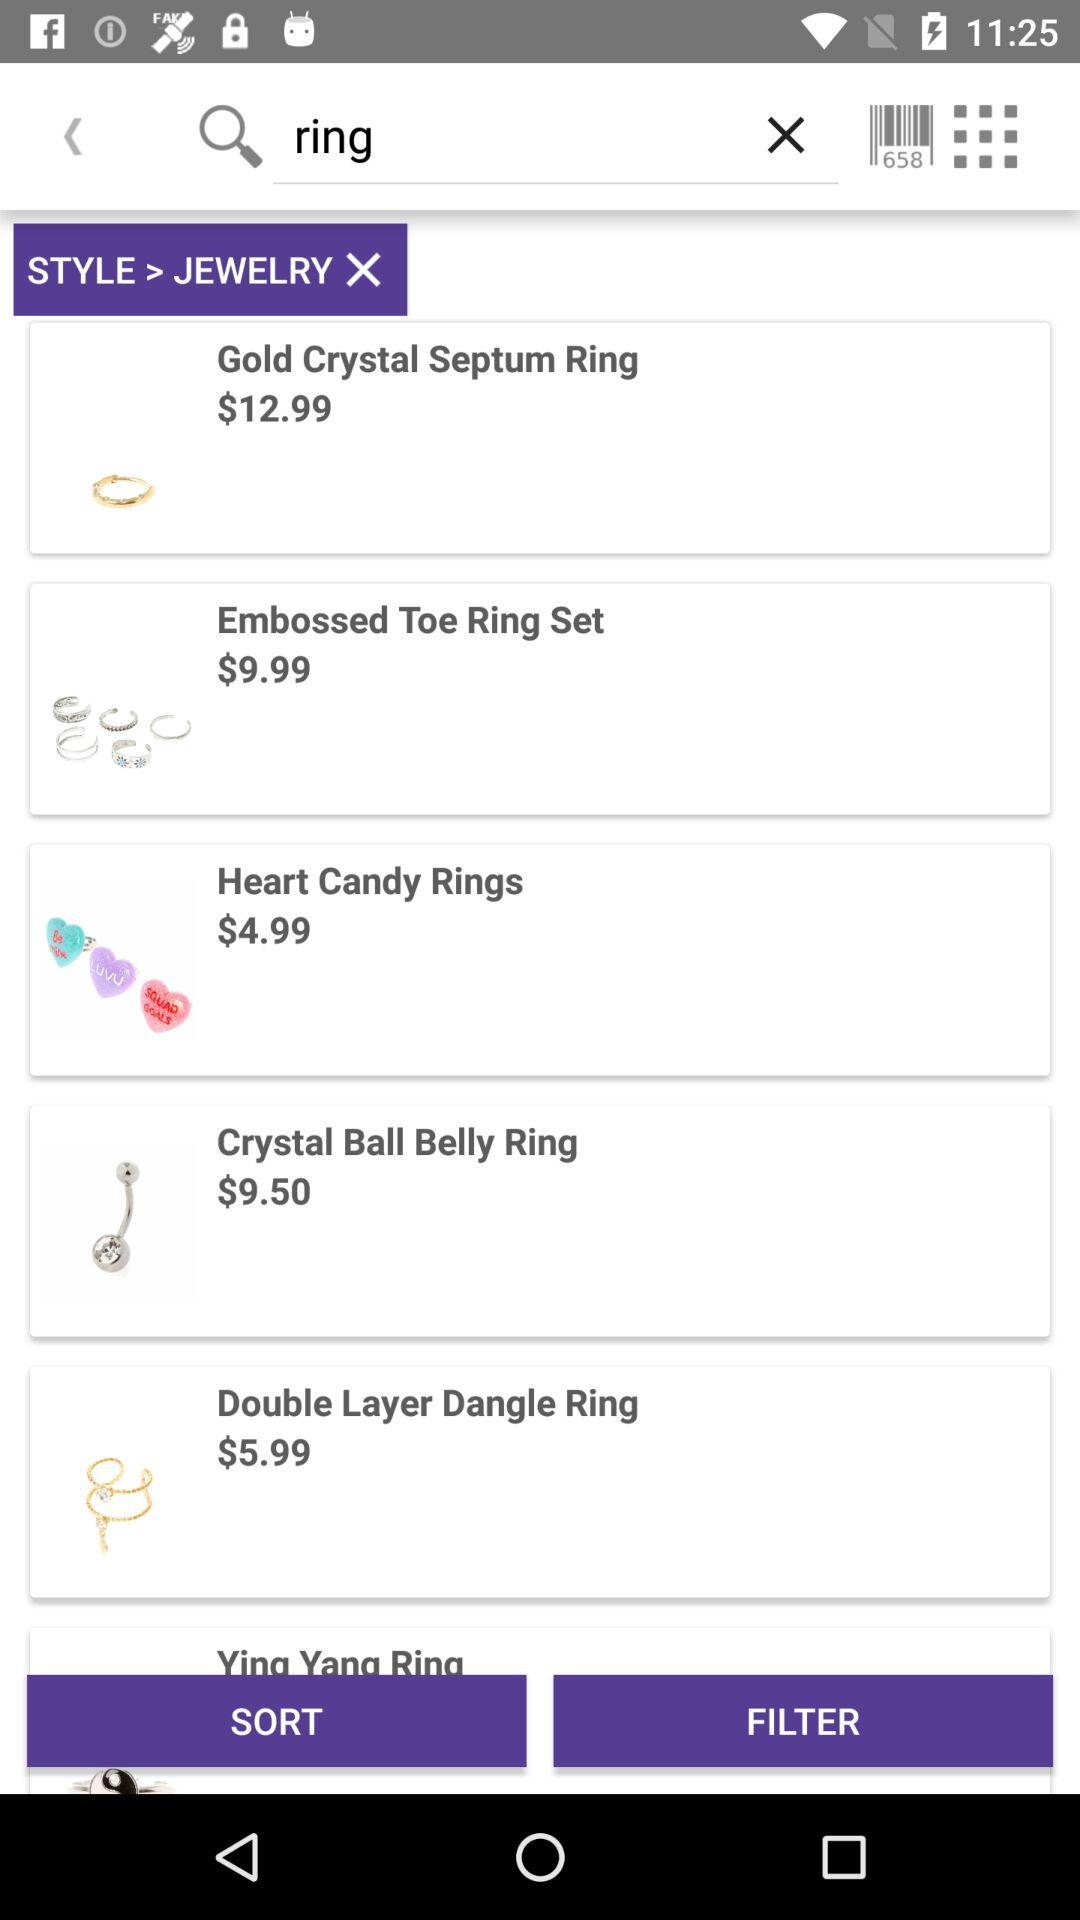What is the price for a crystal ball belly ring? The price for a crystal ball belly ring is $9.50. 